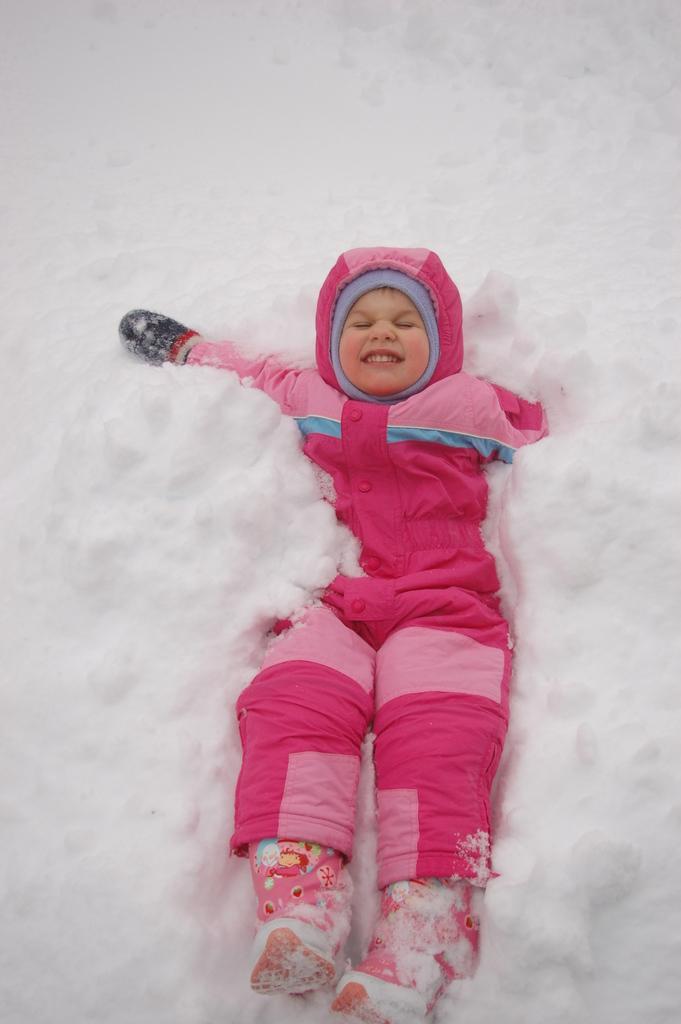Can you describe this image briefly? In this image I can see there is a kid lying on the snow and is wearing a coat, gloves and shoes. 